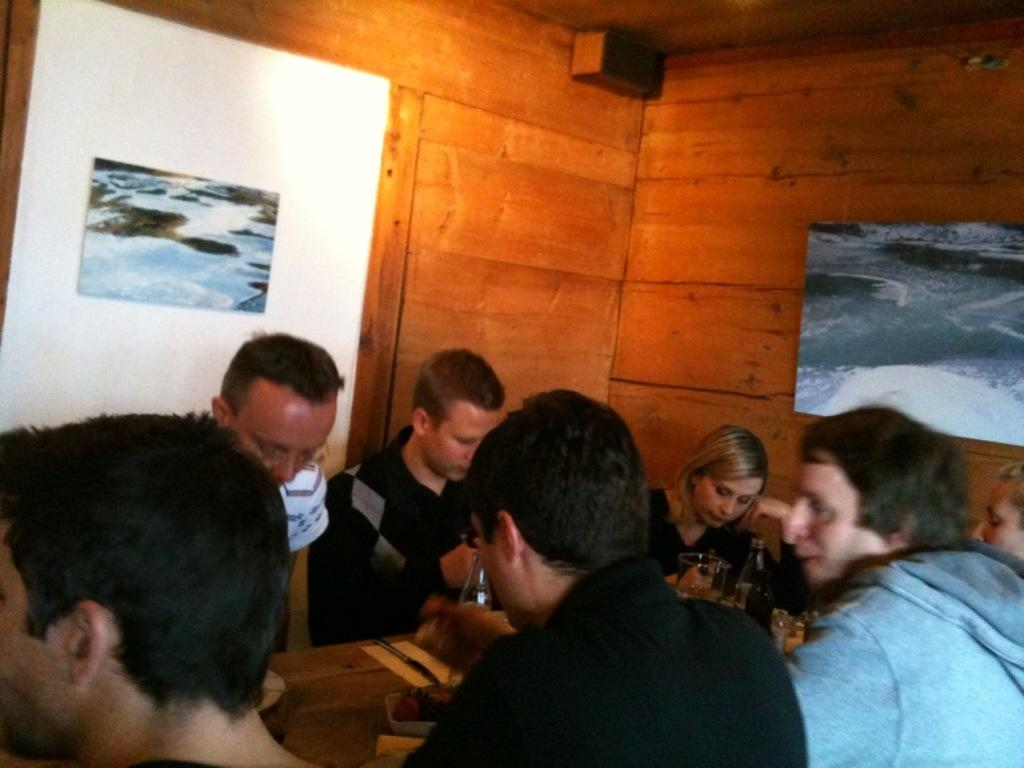How many people are in the image? There is a group of people in the image. What are the people wearing? The people are wearing clothes. Where are the people sitting in the image? The people are sitting in front of a table. What can be found on the table in the image? The table contains bottles. What type of grass is growing on the people's fingers in the image? There is no grass growing on the people's fingers in the image, as they are wearing clothes and sitting in front of a table. 